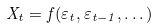Convert formula to latex. <formula><loc_0><loc_0><loc_500><loc_500>X _ { t } = f ( \varepsilon _ { t } , \varepsilon _ { t - 1 } , \dots )</formula> 